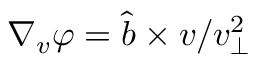Convert formula to latex. <formula><loc_0><loc_0><loc_500><loc_500>\nabla _ { v } \varphi = \hat { b } \times v / v _ { \perp } ^ { 2 }</formula> 